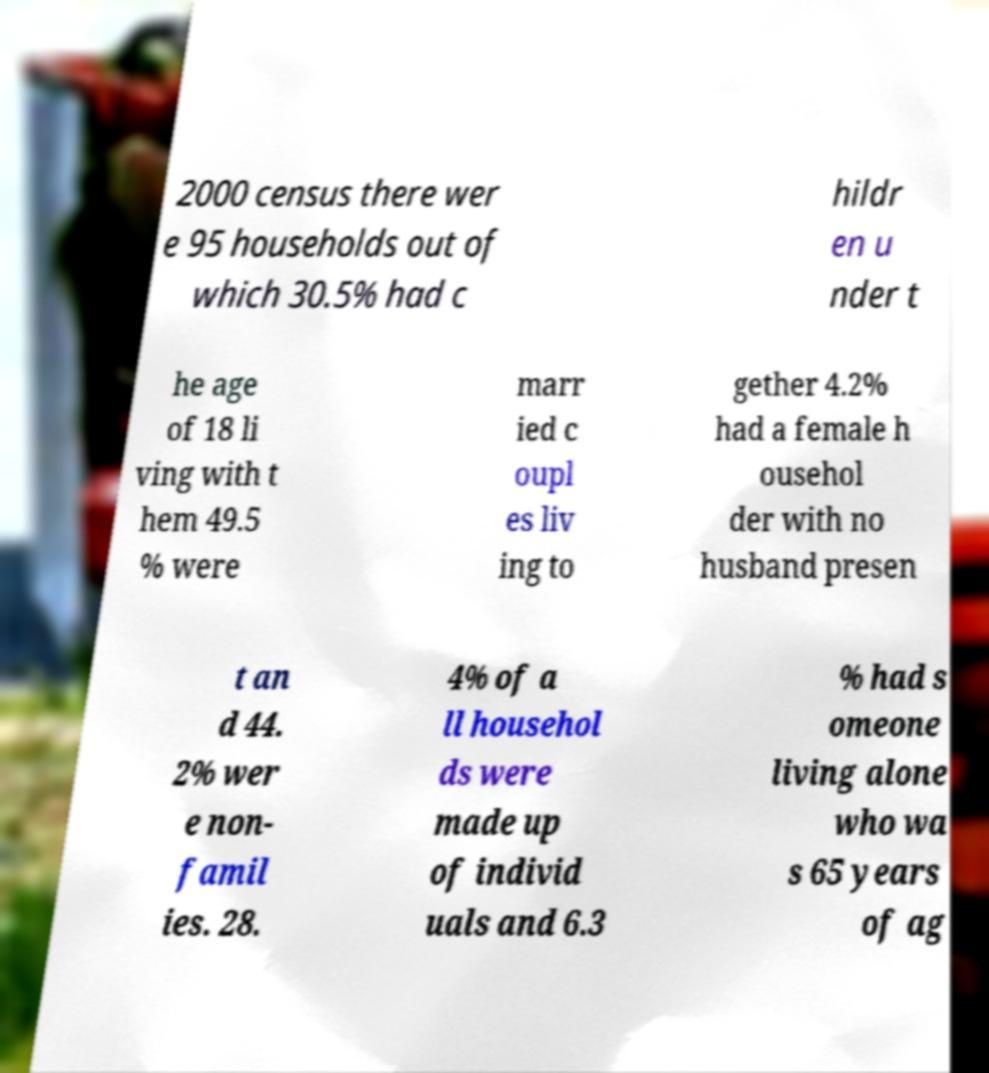Can you read and provide the text displayed in the image?This photo seems to have some interesting text. Can you extract and type it out for me? 2000 census there wer e 95 households out of which 30.5% had c hildr en u nder t he age of 18 li ving with t hem 49.5 % were marr ied c oupl es liv ing to gether 4.2% had a female h ousehol der with no husband presen t an d 44. 2% wer e non- famil ies. 28. 4% of a ll househol ds were made up of individ uals and 6.3 % had s omeone living alone who wa s 65 years of ag 